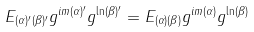Convert formula to latex. <formula><loc_0><loc_0><loc_500><loc_500>E _ { ( \alpha ) ^ { \prime } ( \beta ) ^ { \prime } } g ^ { i m ( \alpha ) ^ { \prime } } g ^ { \ln ( \beta ) ^ { \prime } } = E _ { ( \alpha ) ( \beta ) } g ^ { i m ( \alpha ) } g ^ { \ln ( \beta ) }</formula> 